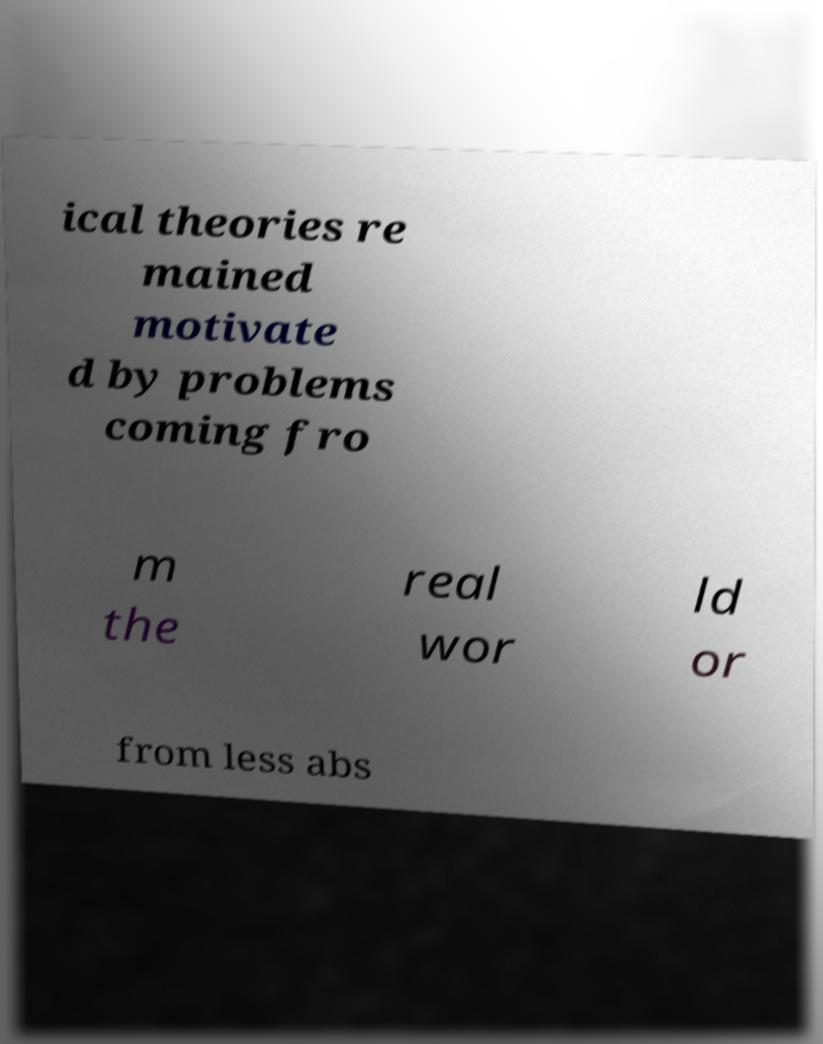For documentation purposes, I need the text within this image transcribed. Could you provide that? ical theories re mained motivate d by problems coming fro m the real wor ld or from less abs 